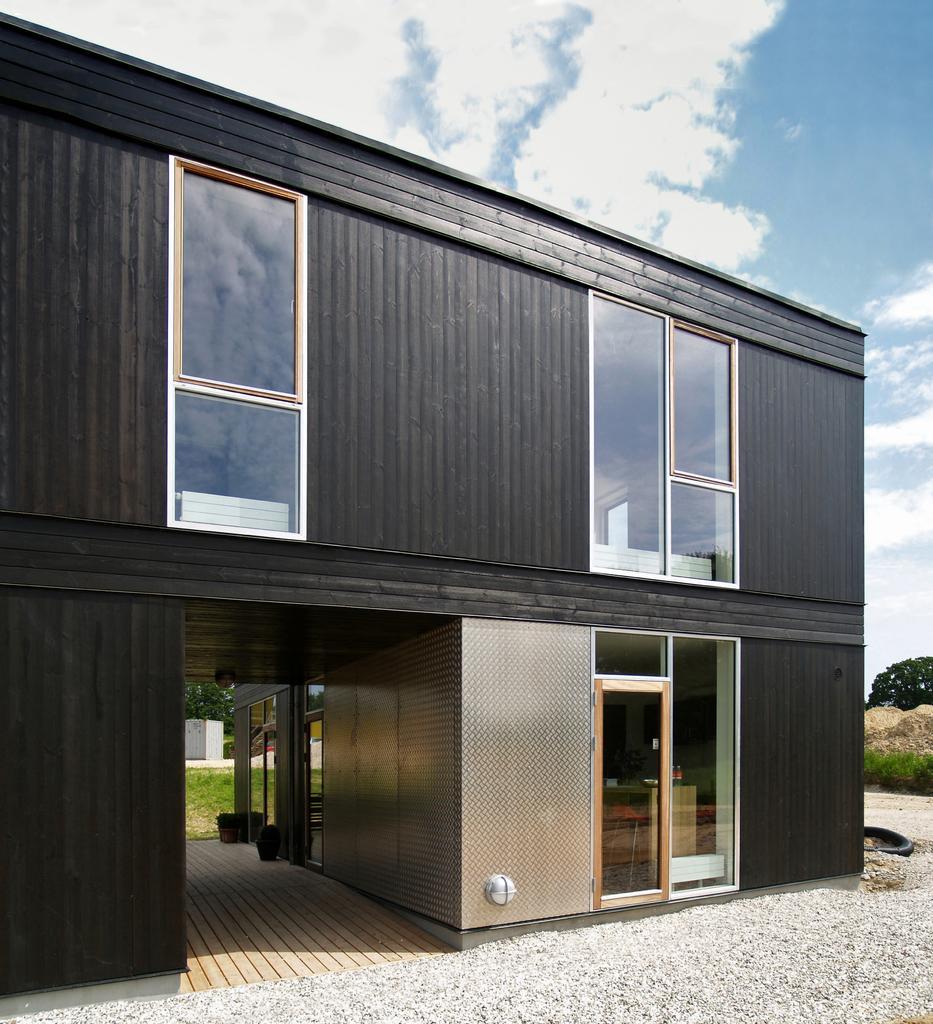Please provide a concise description of this image. This is an outside view. At the bottom, I can see the ground. In the middle of the image there is a building. In the background there are some trees. At the top of the image I can see the sky and clouds. 